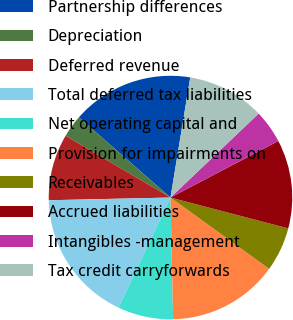Convert chart to OTSL. <chart><loc_0><loc_0><loc_500><loc_500><pie_chart><fcel>Partnership differences<fcel>Depreciation<fcel>Deferred revenue<fcel>Total deferred tax liabilities<fcel>Net operating capital and<fcel>Provision for impairments on<fcel>Receivables<fcel>Accrued liabilities<fcel>Intangibles -management<fcel>Tax credit carryforwards<nl><fcel>16.16%<fcel>2.96%<fcel>8.83%<fcel>17.63%<fcel>7.36%<fcel>14.69%<fcel>5.89%<fcel>11.76%<fcel>4.43%<fcel>10.29%<nl></chart> 